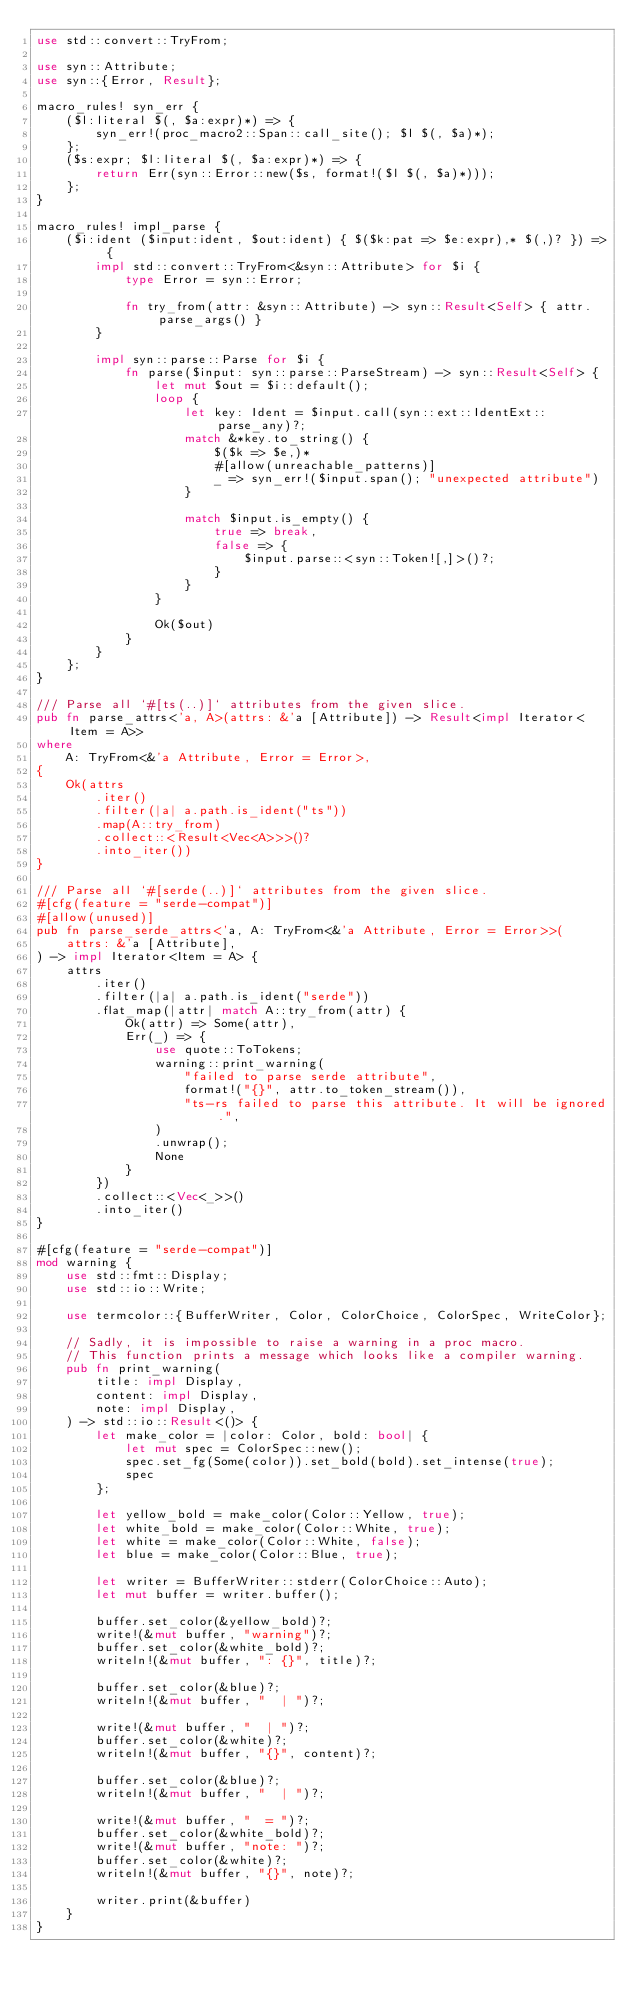<code> <loc_0><loc_0><loc_500><loc_500><_Rust_>use std::convert::TryFrom;

use syn::Attribute;
use syn::{Error, Result};

macro_rules! syn_err {
    ($l:literal $(, $a:expr)*) => {
        syn_err!(proc_macro2::Span::call_site(); $l $(, $a)*);
    };
    ($s:expr; $l:literal $(, $a:expr)*) => {
        return Err(syn::Error::new($s, format!($l $(, $a)*)));
    };
}

macro_rules! impl_parse {
    ($i:ident ($input:ident, $out:ident) { $($k:pat => $e:expr),* $(,)? }) => {
        impl std::convert::TryFrom<&syn::Attribute> for $i {
            type Error = syn::Error;

            fn try_from(attr: &syn::Attribute) -> syn::Result<Self> { attr.parse_args() }
        }

        impl syn::parse::Parse for $i {
            fn parse($input: syn::parse::ParseStream) -> syn::Result<Self> {
                let mut $out = $i::default();
                loop {
                    let key: Ident = $input.call(syn::ext::IdentExt::parse_any)?;
                    match &*key.to_string() {
                        $($k => $e,)*
                        #[allow(unreachable_patterns)]
                        _ => syn_err!($input.span(); "unexpected attribute")
                    }

                    match $input.is_empty() {
                        true => break,
                        false => {
                            $input.parse::<syn::Token![,]>()?;
                        }
                    }
                }

                Ok($out)
            }
        }
    };
}

/// Parse all `#[ts(..)]` attributes from the given slice.
pub fn parse_attrs<'a, A>(attrs: &'a [Attribute]) -> Result<impl Iterator<Item = A>>
where
    A: TryFrom<&'a Attribute, Error = Error>,
{
    Ok(attrs
        .iter()
        .filter(|a| a.path.is_ident("ts"))
        .map(A::try_from)
        .collect::<Result<Vec<A>>>()?
        .into_iter())
}

/// Parse all `#[serde(..)]` attributes from the given slice.
#[cfg(feature = "serde-compat")]
#[allow(unused)]
pub fn parse_serde_attrs<'a, A: TryFrom<&'a Attribute, Error = Error>>(
    attrs: &'a [Attribute],
) -> impl Iterator<Item = A> {
    attrs
        .iter()
        .filter(|a| a.path.is_ident("serde"))
        .flat_map(|attr| match A::try_from(attr) {
            Ok(attr) => Some(attr),
            Err(_) => {
                use quote::ToTokens;
                warning::print_warning(
                    "failed to parse serde attribute",
                    format!("{}", attr.to_token_stream()),
                    "ts-rs failed to parse this attribute. It will be ignored.",
                )
                .unwrap();
                None
            }
        })
        .collect::<Vec<_>>()
        .into_iter()
}

#[cfg(feature = "serde-compat")]
mod warning {
    use std::fmt::Display;
    use std::io::Write;

    use termcolor::{BufferWriter, Color, ColorChoice, ColorSpec, WriteColor};

    // Sadly, it is impossible to raise a warning in a proc macro.
    // This function prints a message which looks like a compiler warning.
    pub fn print_warning(
        title: impl Display,
        content: impl Display,
        note: impl Display,
    ) -> std::io::Result<()> {
        let make_color = |color: Color, bold: bool| {
            let mut spec = ColorSpec::new();
            spec.set_fg(Some(color)).set_bold(bold).set_intense(true);
            spec
        };

        let yellow_bold = make_color(Color::Yellow, true);
        let white_bold = make_color(Color::White, true);
        let white = make_color(Color::White, false);
        let blue = make_color(Color::Blue, true);

        let writer = BufferWriter::stderr(ColorChoice::Auto);
        let mut buffer = writer.buffer();

        buffer.set_color(&yellow_bold)?;
        write!(&mut buffer, "warning")?;
        buffer.set_color(&white_bold)?;
        writeln!(&mut buffer, ": {}", title)?;

        buffer.set_color(&blue)?;
        writeln!(&mut buffer, "  | ")?;

        write!(&mut buffer, "  | ")?;
        buffer.set_color(&white)?;
        writeln!(&mut buffer, "{}", content)?;

        buffer.set_color(&blue)?;
        writeln!(&mut buffer, "  | ")?;

        write!(&mut buffer, "  = ")?;
        buffer.set_color(&white_bold)?;
        write!(&mut buffer, "note: ")?;
        buffer.set_color(&white)?;
        writeln!(&mut buffer, "{}", note)?;

        writer.print(&buffer)
    }
}
</code> 